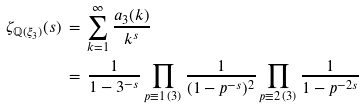Convert formula to latex. <formula><loc_0><loc_0><loc_500><loc_500>\zeta _ { \mathbb { Q } ( \xi _ { 3 } ) } ( s ) & \, = \, \sum _ { k = 1 } ^ { \infty } \frac { a _ { 3 } ( k ) } { k ^ { s } } \\ & \, = \, \frac { 1 } { 1 - 3 ^ { - s } } \prod _ { p \equiv 1 \, ( 3 ) } \frac { 1 } { ( 1 - p ^ { - s } ) ^ { 2 } } \prod _ { p \equiv 2 \, ( 3 ) } \frac { 1 } { 1 - p ^ { - 2 s } }</formula> 